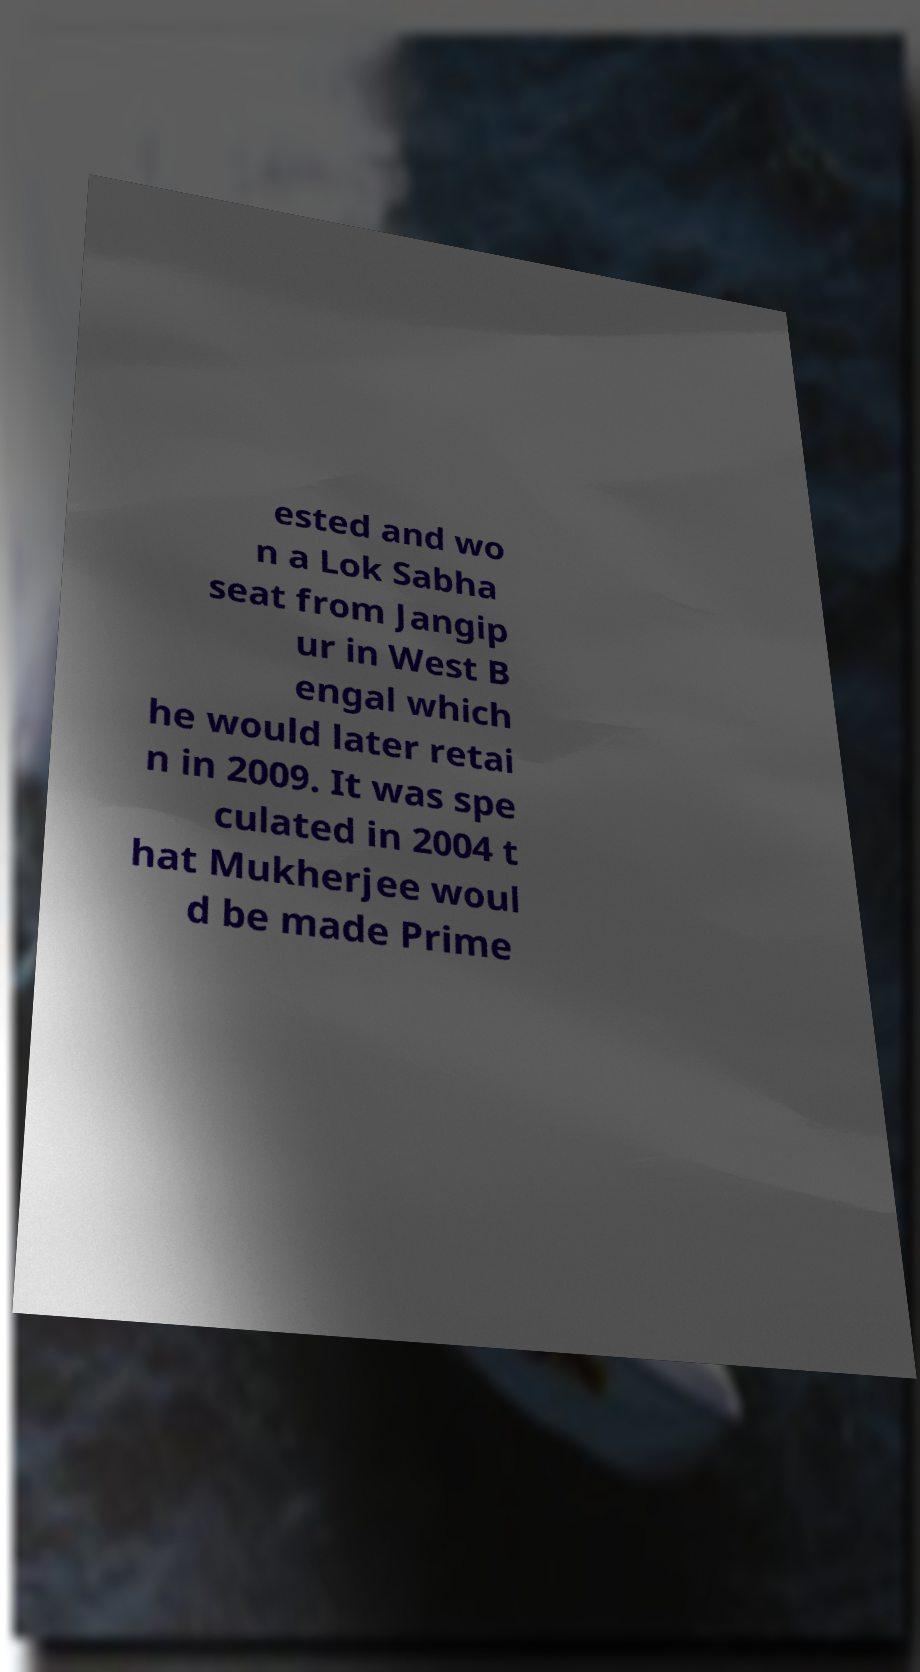Can you accurately transcribe the text from the provided image for me? ested and wo n a Lok Sabha seat from Jangip ur in West B engal which he would later retai n in 2009. It was spe culated in 2004 t hat Mukherjee woul d be made Prime 